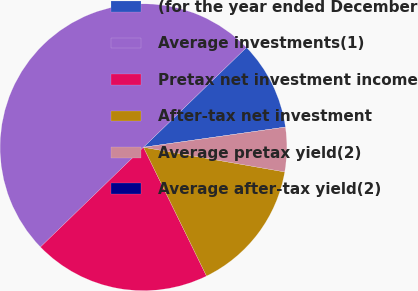Convert chart to OTSL. <chart><loc_0><loc_0><loc_500><loc_500><pie_chart><fcel>(for the year ended December<fcel>Average investments(1)<fcel>Pretax net investment income<fcel>After-tax net investment<fcel>Average pretax yield(2)<fcel>Average after-tax yield(2)<nl><fcel>10.0%<fcel>50.0%<fcel>20.0%<fcel>15.0%<fcel>5.0%<fcel>0.0%<nl></chart> 